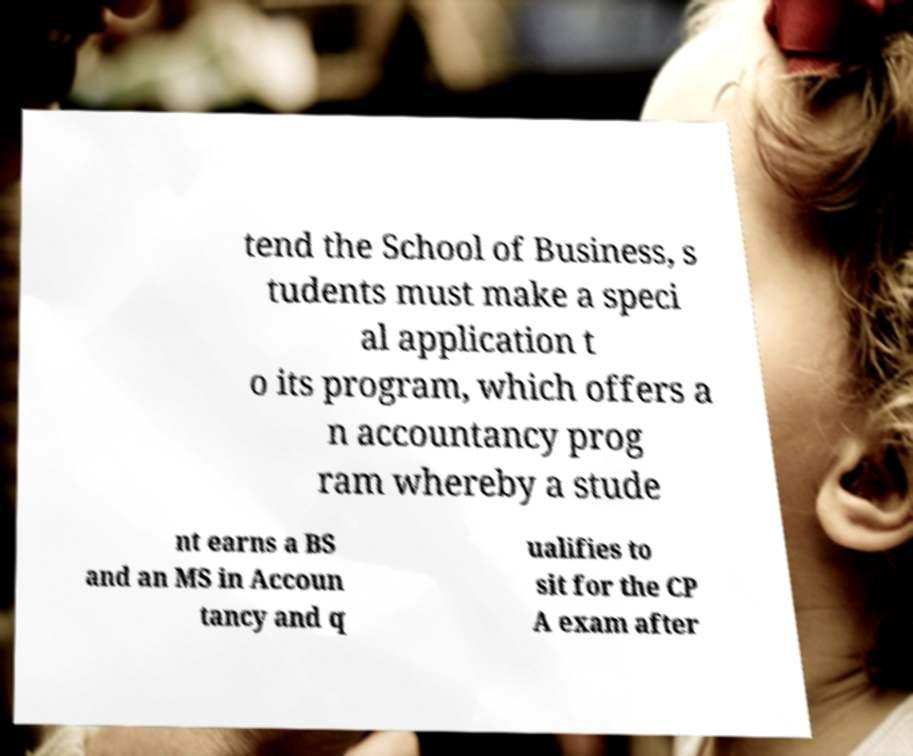There's text embedded in this image that I need extracted. Can you transcribe it verbatim? tend the School of Business, s tudents must make a speci al application t o its program, which offers a n accountancy prog ram whereby a stude nt earns a BS and an MS in Accoun tancy and q ualifies to sit for the CP A exam after 